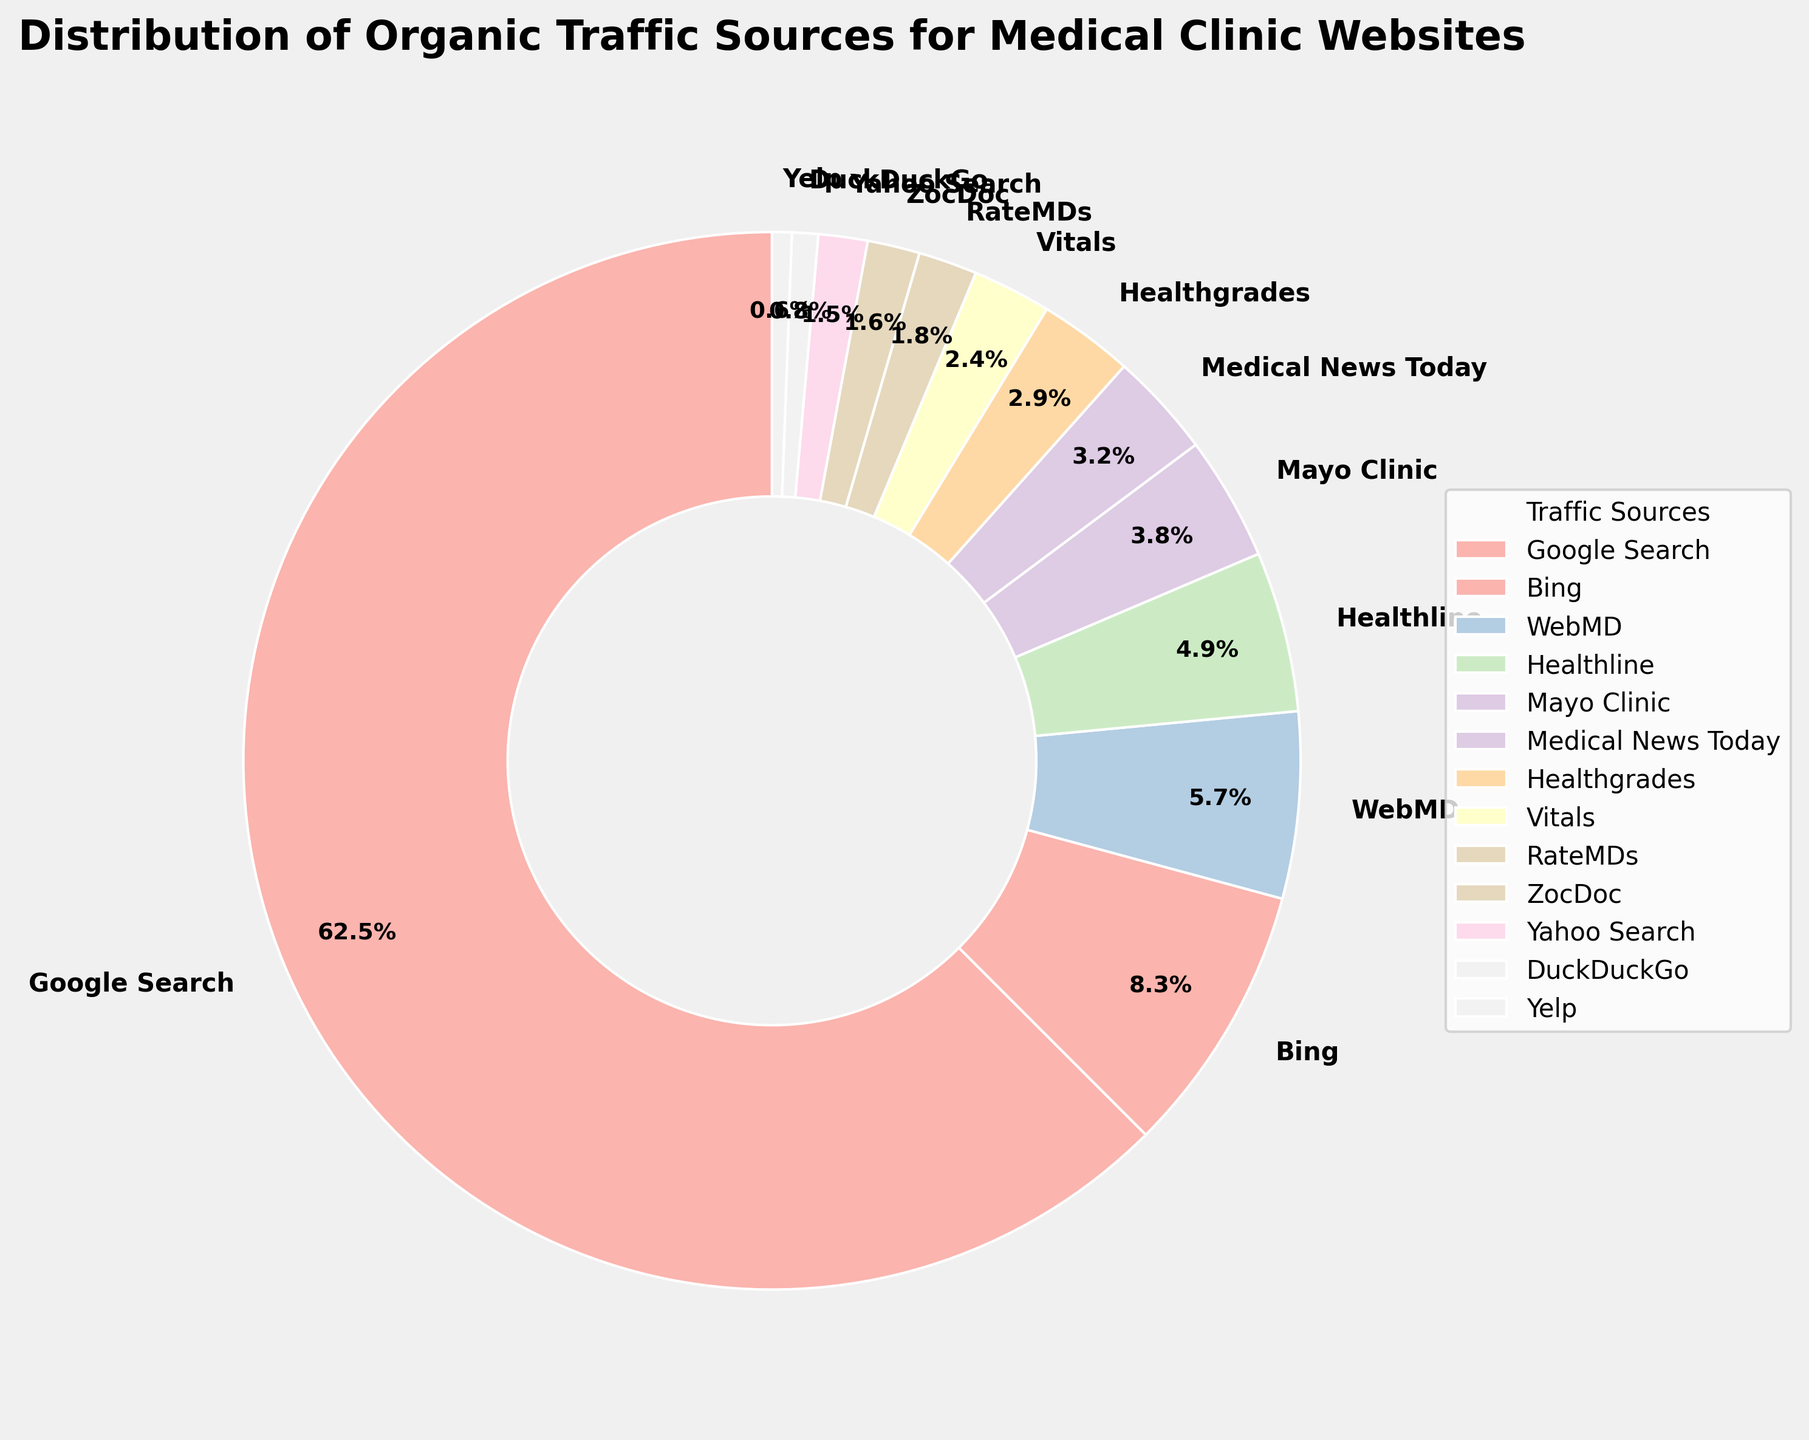Which traffic source contributes the most to organic traffic? The largest portion of the pie chart is colored for Google Search, which means it has the highest percentage.
Answer: Google Search What is the total percentage of traffic coming from search engines like Google and Bing combined? Google Search has 62.5% and Bing has 8.3%; summing these gives 62.5 + 8.3 = 70.8%.
Answer: 70.8% Which source provides less traffic, Yelp or RateMDs? On the pie chart, the slice for Yelp is smaller compared to RateMDs. Yelp has 0.6% while RateMDs has 1.8%.
Answer: Yelp What is the difference in traffic percentage between WebMD and Mayo Clinic? WebMD accounts for 5.7% while Mayo Clinic accounts for 3.8%; the difference is 5.7 - 3.8 = 1.9%.
Answer: 1.9% Which source has nearly the same percentage as Vitals? Vitals has 2.4%, which is very close to Healthgrades at 2.9%.
Answer: Healthgrades How much higher is the percentage of traffic from Yahoo Search compared to DuckDuckGo? Yahoo Search has 1.5% and DuckDuckGo has 0.8%; the difference is 1.5 - 0.8 = 0.7%.
Answer: 0.7% Combine the traffic percentages from Healthline and Medical News Today. What is the combined total? Healthline is 4.9% and Medical News Today is 3.2%; summing these gives 4.9 + 3.2 = 8.1%.
Answer: 8.1% Are there any sources with traffic contributions below 1%? If so, name them. The sources with less than 1% are DuckDuckGo and Yelp, shown on the smaller slices of the pie chart.
Answer: DuckDuckGo and Yelp Which two sources are the smallest contributors to organic traffic? The smallest slices in the pie chart representing the lowest percentages are DuckDuckGo (0.8%) and Yelp (0.6%).
Answer: DuckDuckGo and Yelp 